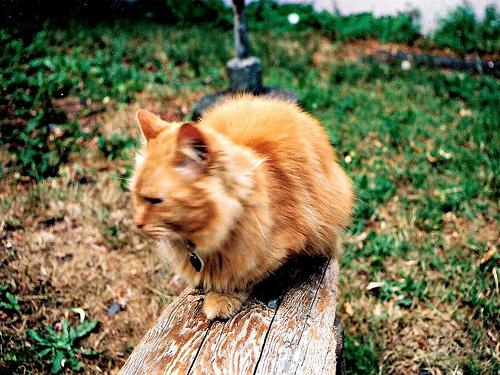Question: what animal is seen?
Choices:
A. Dog.
B. Bunny.
C. Cat.
D. Horse.
Answer with the letter. Answer: C Question: how many cats are there?
Choices:
A. 2.
B. 1.
C. 3.
D. 5.
Answer with the letter. Answer: B Question: how is the day?
Choices:
A. Hot.
B. Sunny.
C. Windy.
D. Cloudy.
Answer with the letter. Answer: B 